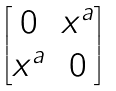Convert formula to latex. <formula><loc_0><loc_0><loc_500><loc_500>\begin{bmatrix} 0 & x ^ { a } \\ x ^ { a } & 0 \end{bmatrix}</formula> 